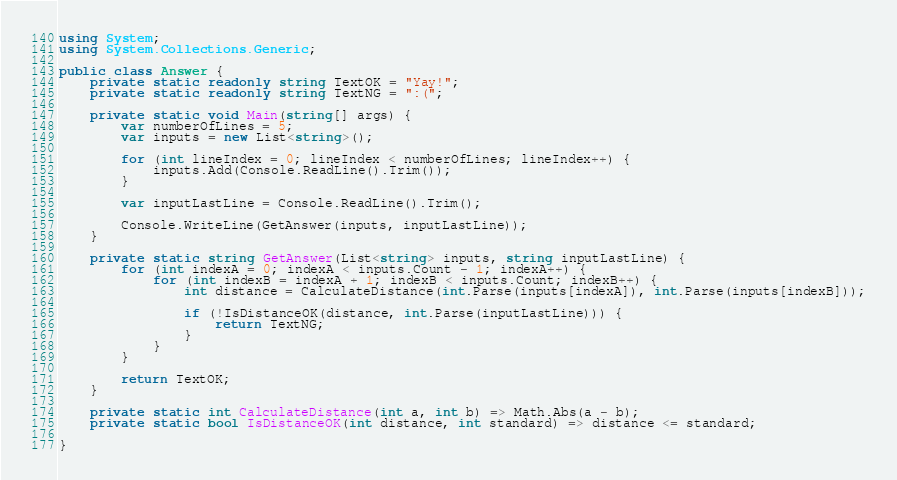Convert code to text. <code><loc_0><loc_0><loc_500><loc_500><_C#_>using System;
using System.Collections.Generic;

public class Answer {
    private static readonly string TextOK = "Yay!";
    private static readonly string TextNG = ":(";
  
    private static void Main(string[] args) {
        var numberOfLines = 5;
        var inputs = new List<string>();
        
        for (int lineIndex = 0; lineIndex < numberOfLines; lineIndex++) {
            inputs.Add(Console.ReadLine().Trim());
        }

        var inputLastLine = Console.ReadLine().Trim();
        
        Console.WriteLine(GetAnswer(inputs, inputLastLine));
    }
  
    private static string GetAnswer(List<string> inputs, string inputLastLine) {
        for (int indexA = 0; indexA < inputs.Count - 1; indexA++) {
            for (int indexB = indexA + 1; indexB < inputs.Count; indexB++) {
                int distance = CalculateDistance(int.Parse(inputs[indexA]), int.Parse(inputs[indexB]));

                if (!IsDistanceOK(distance, int.Parse(inputLastLine))) {
                    return TextNG;
                }
            }
        }

        return TextOK;
    }

    private static int CalculateDistance(int a, int b) => Math.Abs(a - b);
    private static bool IsDistanceOK(int distance, int standard) => distance <= standard;

}</code> 